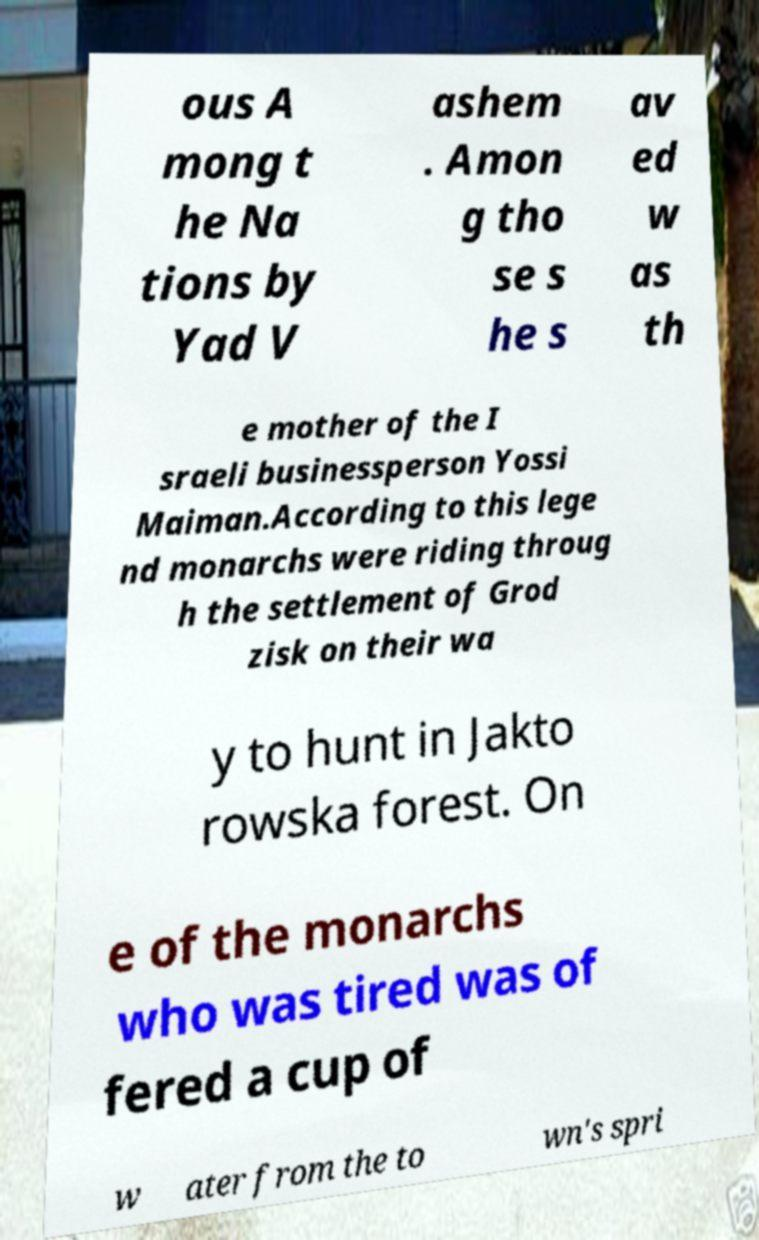Can you read and provide the text displayed in the image?This photo seems to have some interesting text. Can you extract and type it out for me? ous A mong t he Na tions by Yad V ashem . Amon g tho se s he s av ed w as th e mother of the I sraeli businessperson Yossi Maiman.According to this lege nd monarchs were riding throug h the settlement of Grod zisk on their wa y to hunt in Jakto rowska forest. On e of the monarchs who was tired was of fered a cup of w ater from the to wn's spri 